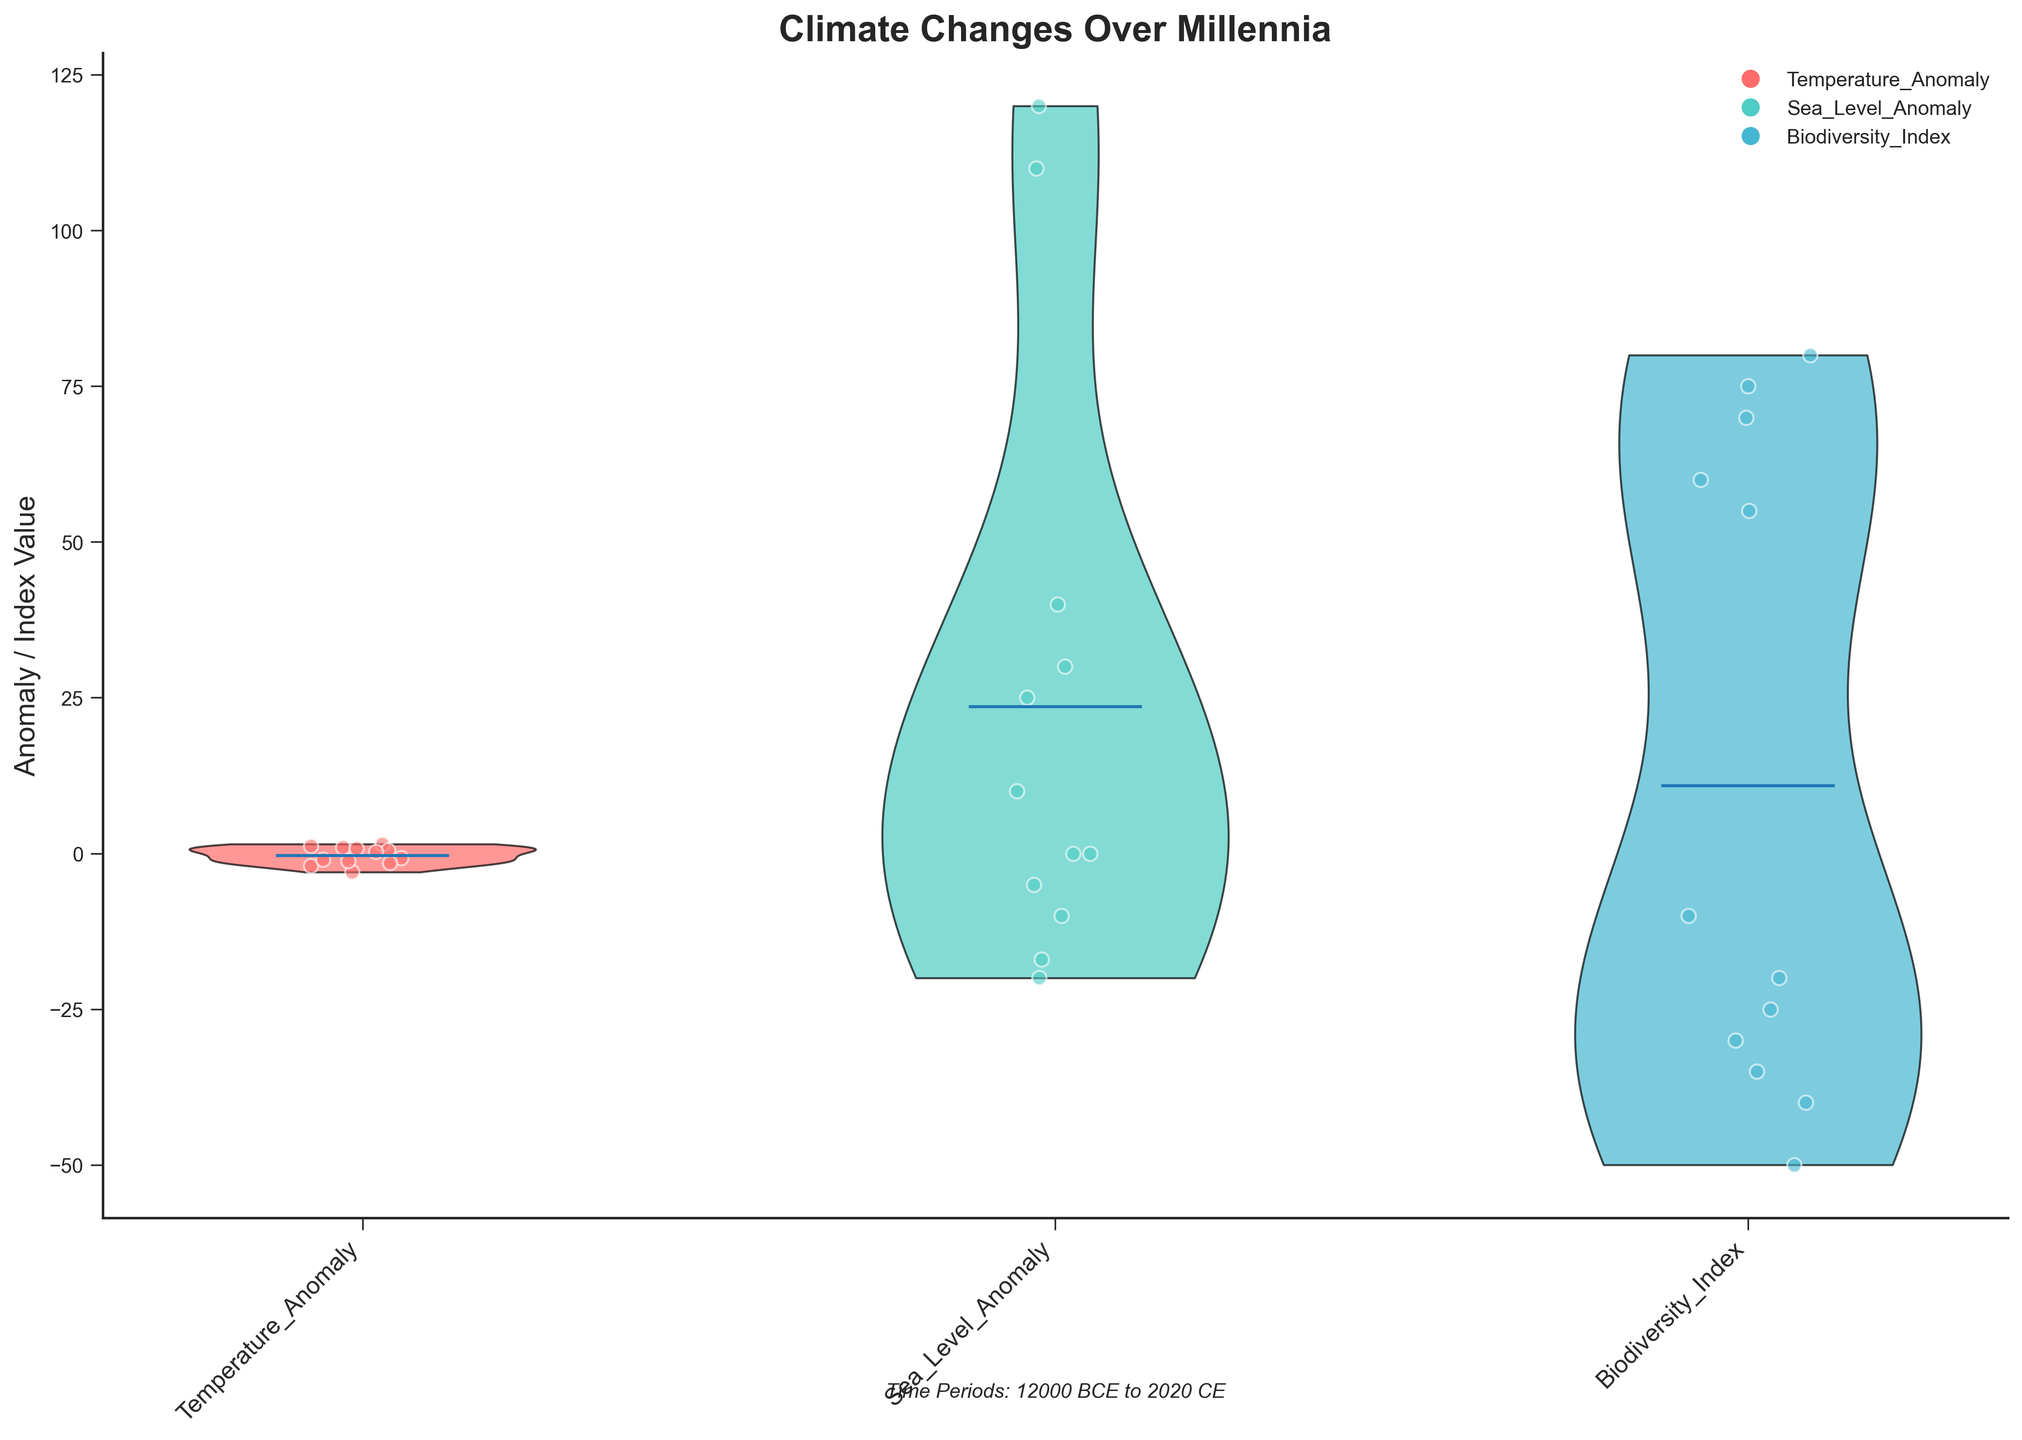What are the variables displayed on the X-axis? The X-axis shows three variables: Temperature Anomaly, Sea Level Anomaly, and Biodiversity Index. This can be determined by reading the labels on the X-axis of the figure.
Answer: Temperature Anomaly, Sea Level Anomaly, Biodiversity Index What does the Y-axis represent? The Y-axis represents the 'Anomaly / Index Value,' which is evident from the Y-axis label in the figure.
Answer: Anomaly / Index Value Which variable has the highest mean value? The highest mean value can be observed by looking at the white line indicating the mean within each violin plot. Temperature Anomaly has the highest mean as its white line is above the others.
Answer: Temperature Anomaly How do the color-coded jittered points correspond to the variables? Each variable has a distinct color for jittered points: red for Temperature Anomaly, teal for Sea Level Anomaly, and a different shade of blue for Biodiversity Index. These colors match the respective violin plots.
Answer: Red: Temperature Anomaly, Teal: Sea Level Anomaly, Blue: Biodiversity Index Which time period has the highest Temperature Anomaly? Look at the scatter points on the Temperature Anomaly violin plot and identify the highest value, which corresponds to the Holocene Climate Optimum period.
Answer: Holocene Climate Optimum Among the time periods, which one shows the greatest negative effect on Biodiversity Index? The most negative value in the Biodiversity Index violin plot, which represents 'Year Without a Summer' due to Mount Tambora eruption with a Biodiversity Index of -50.
Answer: Year Without a Summer What can you infer about sea levels during the Modern Industrial Era? Observing the scatter points within the Sea Level Anomaly violin plot shows that the Modern Industrial Era has a slightly negative anomaly of -10, indicating a decrease.
Answer: Slightly negative anomaly of -10 Compare the Biodiversity Index during the Roman Warm Period and the Younger Dryas Event. For the Roman Warm Period, the Biodiversity Index is 60, while for the Younger Dryas Event, it is -30. By comparing these values, the Roman Warm Period has a significantly higher Biodiversity Index.
Answer: Roman Warm Period is 60, Younger Dryas Event is -30 What is the range of Temperature Anomalies observed in the dataset? The range can be calculated by identifying the highest and lowest points in the Temperature Anomaly violin plot, which are 1.5 during the Holocene Climate Optimum and -3.0 during the End of Last Glacial Maximum, respectively. The range is 4.5 (-3.0 to 1.5).
Answer: 4.5 Which time periods experienced negative anomalies across all three variables? Analyzing the scatter points across all three violin plots, the Younger Dryas Event, Volcanic Activity and Justinian Plague Effects, and the 'Year Without a Summer' show negative values across Temperature Anomaly, Sea Level Anomaly, and Biodiversity Index.
Answer: Younger Dryas Event, Volcanic Activity and Justinian Plague Effects, 'Year Without a Summer' 